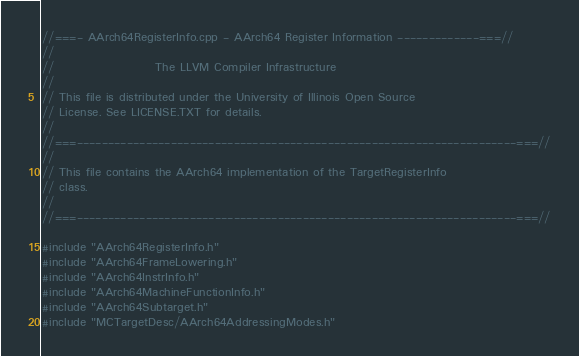Convert code to text. <code><loc_0><loc_0><loc_500><loc_500><_C++_>//===- AArch64RegisterInfo.cpp - AArch64 Register Information -------------===//
//
//                     The LLVM Compiler Infrastructure
//
// This file is distributed under the University of Illinois Open Source
// License. See LICENSE.TXT for details.
//
//===----------------------------------------------------------------------===//
//
// This file contains the AArch64 implementation of the TargetRegisterInfo
// class.
//
//===----------------------------------------------------------------------===//

#include "AArch64RegisterInfo.h"
#include "AArch64FrameLowering.h"
#include "AArch64InstrInfo.h"
#include "AArch64MachineFunctionInfo.h"
#include "AArch64Subtarget.h"
#include "MCTargetDesc/AArch64AddressingModes.h"</code> 